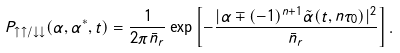<formula> <loc_0><loc_0><loc_500><loc_500>P _ { \uparrow \uparrow / \downarrow \downarrow } ( \alpha , \alpha ^ { * } , t ) = \frac { 1 } { 2 \pi \bar { n } _ { r } } \exp \left [ - \frac { | \alpha \mp ( - 1 ) ^ { n + 1 } \tilde { \alpha } ( t , n \tau _ { 0 } ) | ^ { 2 } } { \bar { n } _ { r } } \right ] .</formula> 